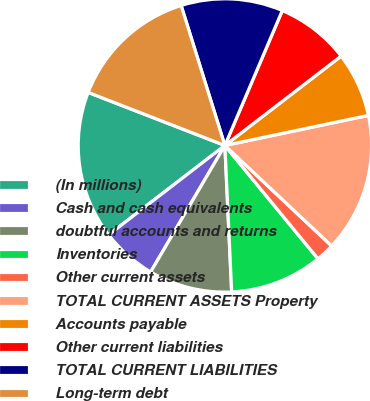Convert chart to OTSL. <chart><loc_0><loc_0><loc_500><loc_500><pie_chart><fcel>(In millions)<fcel>Cash and cash equivalents<fcel>doubtful accounts and returns<fcel>Inventories<fcel>Other current assets<fcel>TOTAL CURRENT ASSETS Property<fcel>Accounts payable<fcel>Other current liabilities<fcel>TOTAL CURRENT LIABILITIES<fcel>Long-term debt<nl><fcel>16.32%<fcel>6.12%<fcel>9.18%<fcel>10.2%<fcel>2.04%<fcel>15.3%<fcel>7.14%<fcel>8.16%<fcel>11.22%<fcel>14.28%<nl></chart> 